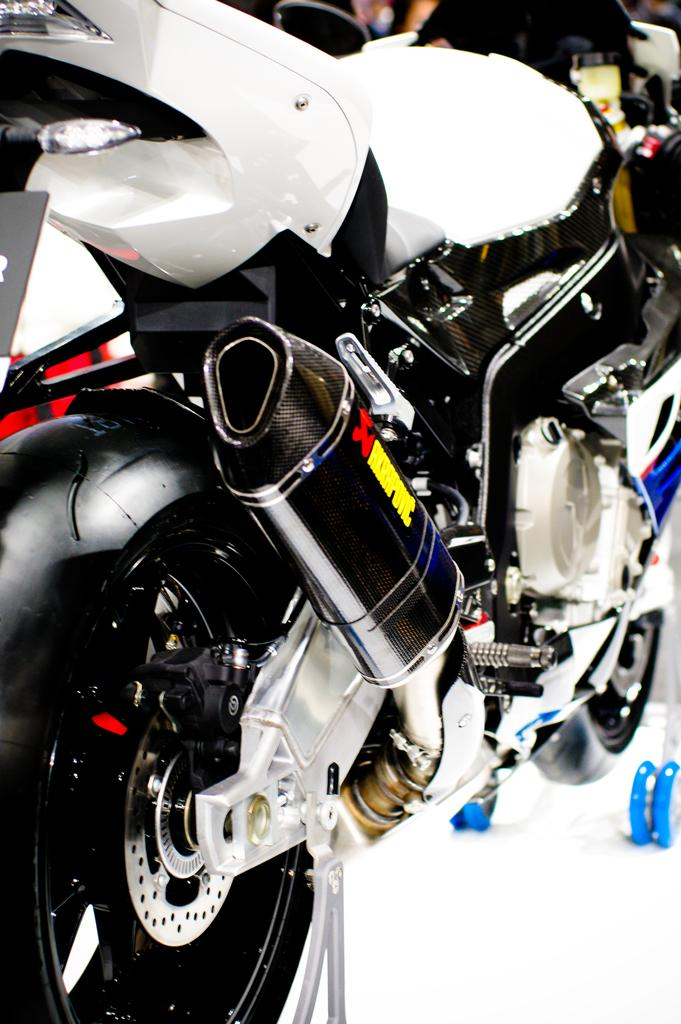What type of vehicle is in the image? There is a motor bicycle in the image. What type of bushes can be seen growing on the motor bicycle in the image? There are no bushes present on the motor bicycle in the image. 